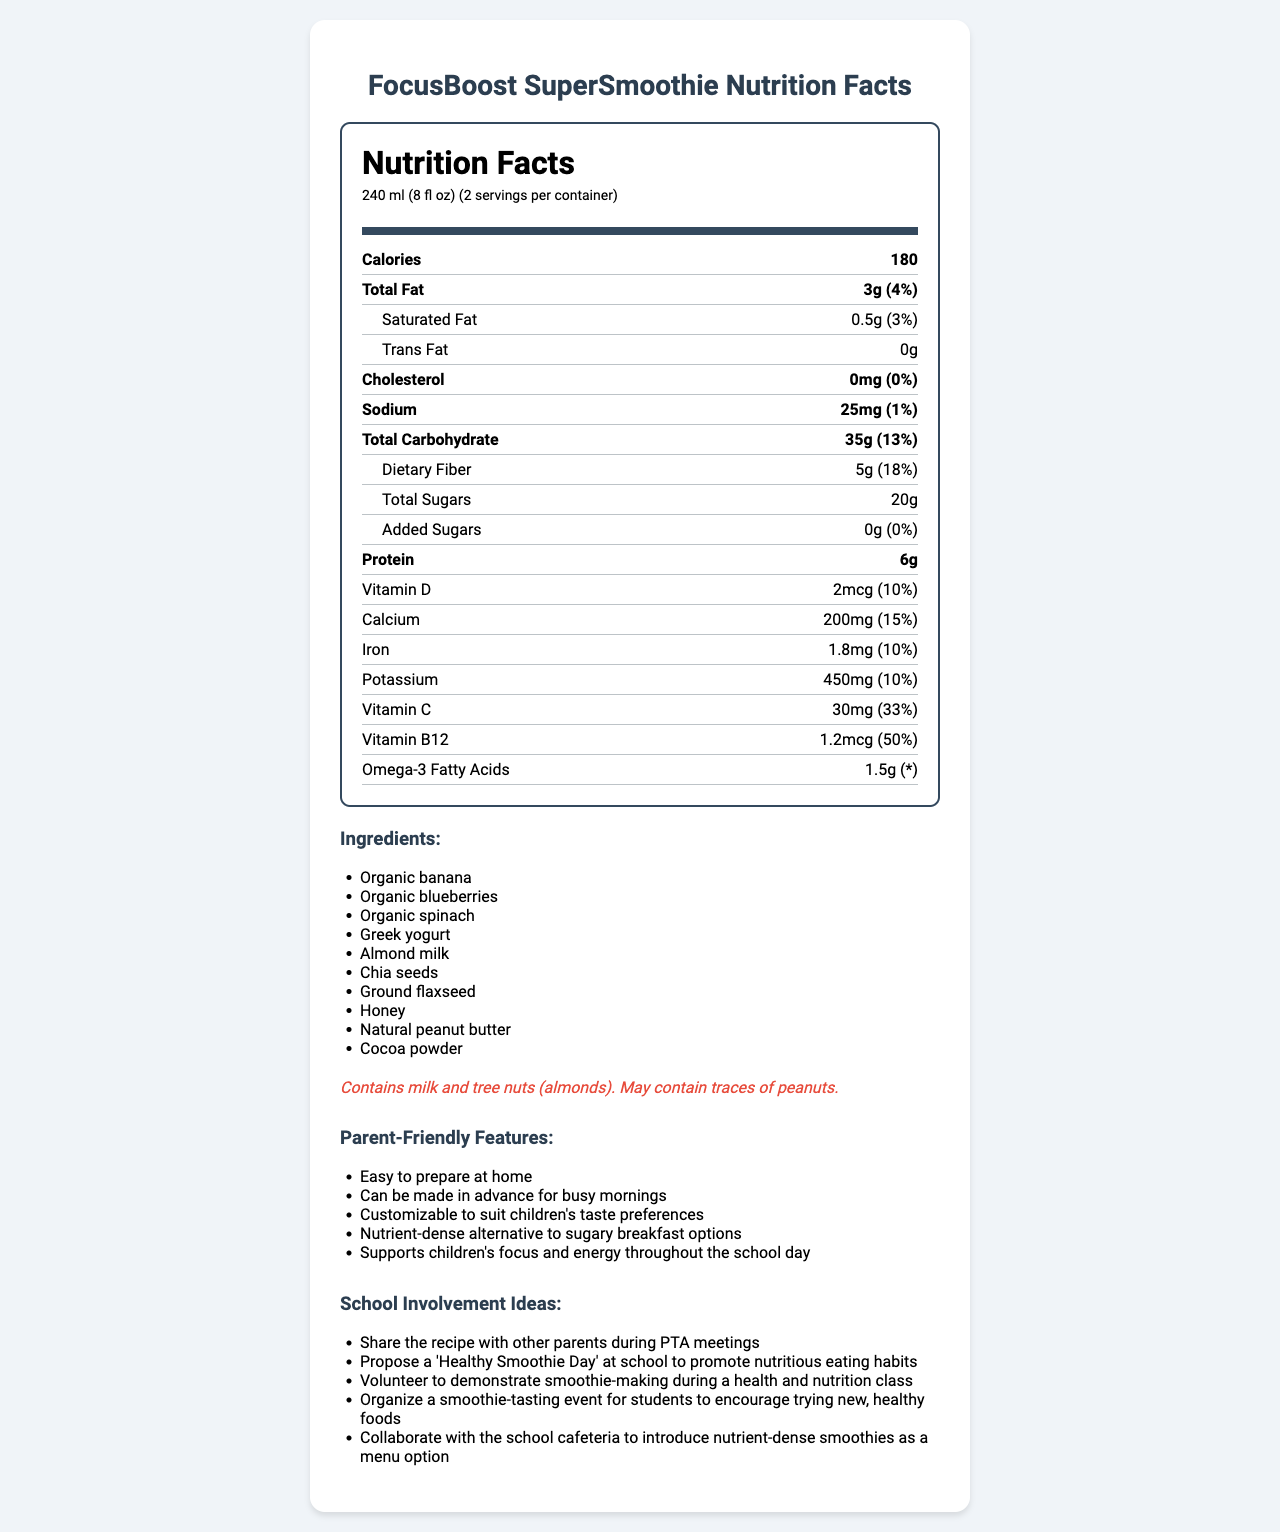what is the serving size? The serving size is stated explicitly on the document as "240 ml (8 fl oz)."
Answer: 240 ml (8 fl oz) how many calories are in one serving? The document lists the calories per serving as 180.
Answer: 180 how much total sugar is included in a serving? The document mentions that the total sugar per serving is 20g.
Answer: 20g what is the daily value percentage of vitamin C per serving? The daily value percentage for vitamin C per serving is listed as 33%.
Answer: 33% how much dietary fiber is in one serving? The dietary fiber per serving is explicitly stated as 5g.
Answer: 5g how many servings are there per container? A. 1 B. 2 C. 3 D. 4 The document specifies that there are 2 servings per container.
Answer: B. 2 which of the following ingredients in FocusBoost SuperSmoothie may cause an allergic reaction? A. Bananas B. Blueberries C. Almonds D. Spinach The allergen information in the document states that the product contains tree nuts (almonds).
Answer: C. Almonds does this product contain added sugars? The document indicates that there are 0g of added sugars per serving.
Answer: No can you summarize the parent-friendly features and school involvement ideas mentioned in the document? The document provides multiple parent-friendly features and school involvement ideas to help promote nutritious eating habits for children.
Answer: The document emphasizes that FocusBoost SuperSmoothie is easy to prepare at home, can be made in advance, is customizable, and is a nutrient-dense alternative to sugary breakfast options. For school involvement, it suggests sharing the recipe during PTA meetings, proposing a 'Healthy Smoothie Day,' volunteering for smoothie-making demonstrations, organizing smoothie-tasting events, and collaborating with the school cafeteria to introduce these smoothies. what percentage of daily calcium does one serving provide? The document states that one serving provides 15% of the daily value of calcium.
Answer: 15% what kind of milk is used in the FocusBoost SuperSmoothie? The document lists almond milk as one of the ingredients.
Answer: Almond milk which vitamin has the highest daily value percentage per serving? A. Vitamin D B. Calcium C. Vitamin C D. Vitamin B12 The daily value percentages are Vitamin D (10%), Calcium (15%), Vitamin C (33%), and Vitamin B12 (50%). Vitamin B12 has the highest daily value percentage.
Answer: D. Vitamin B12 does this product contain trans fat? The document lists trans fat as "0g."
Answer: No how much protein is in one serving? The document mentions that there are 6g of protein per serving.
Answer: 6g are there any ingredients in the smoothie that could trigger a peanut allergy? The allergen information states that the product may contain traces of peanuts.
Answer: Yes what specific idea does the document suggest for promoting healthier eating habits at school? One of the ideas listed is to propose a 'Healthy Smoothie Day' at school.
Answer: Propose a 'Healthy Smoothie Day' at school to promote nutritious eating habits is there enough information to determine whether the FocusBoost SuperSmoothie contains caffeine? The document does not provide any information about whether it contains caffeine.
Answer: Not enough information 